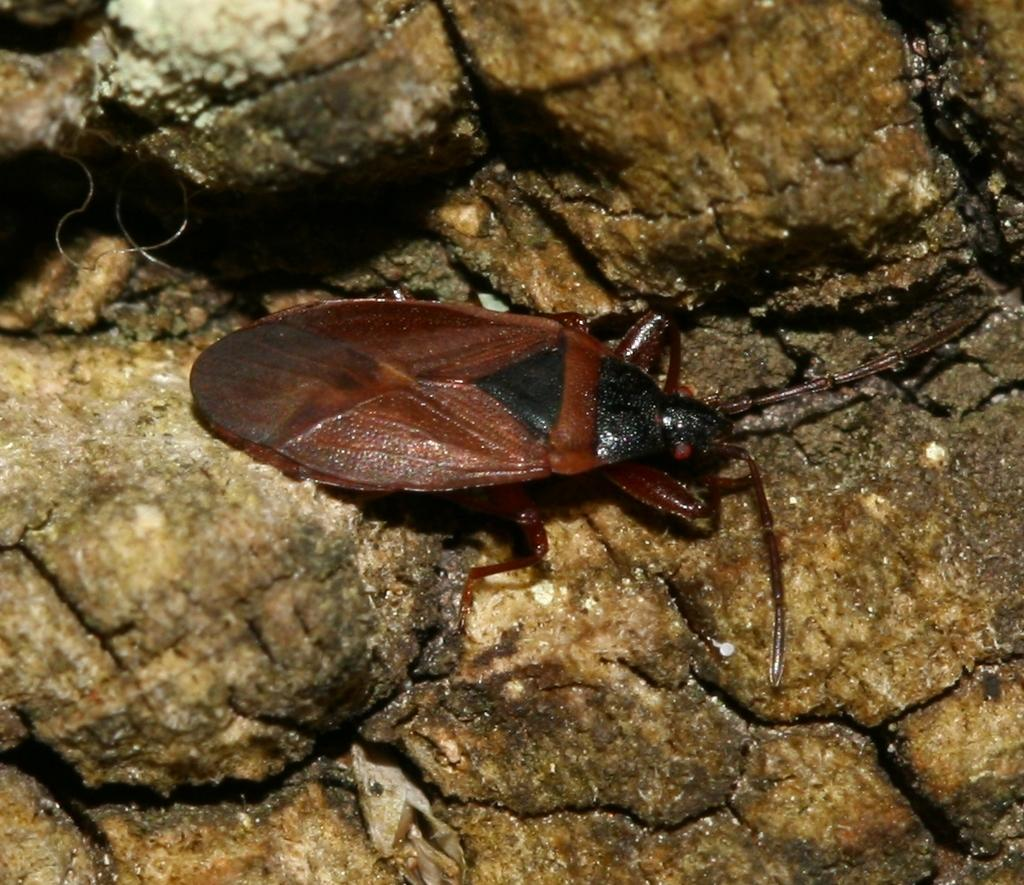What is the main subject in the center of the image? There is an insect in the center of the image. What is the insect resting on? The insect is on a rock. What can be seen in the background of the image? There are rocks visible in the background of the image. How does the insect contribute to the knowledge of the ground in the image? The insect does not contribute to the knowledge of the ground in the image; it is simply resting on a rock. 